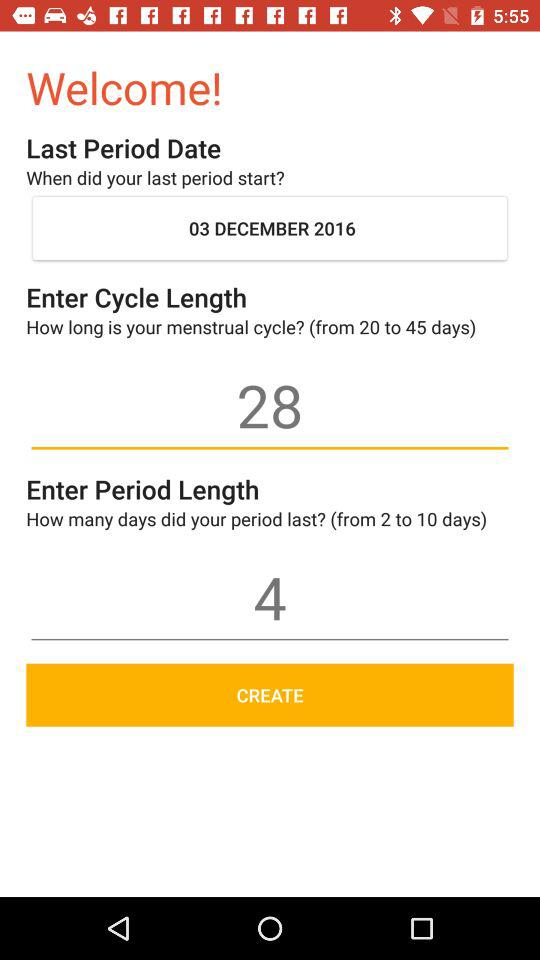What is the period length? The period length is 4. 